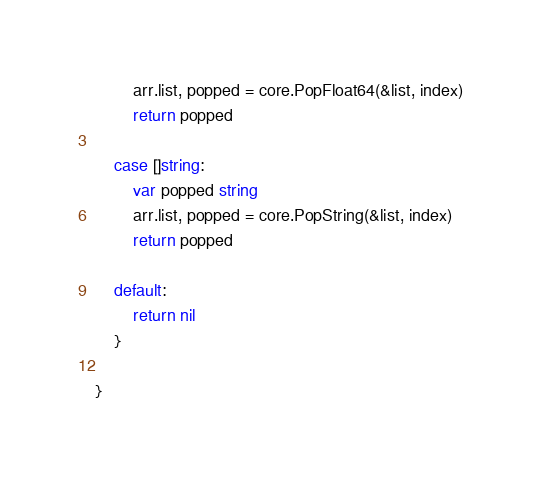<code> <loc_0><loc_0><loc_500><loc_500><_Go_>		arr.list, popped = core.PopFloat64(&list, index)
		return popped

	case []string:
		var popped string
		arr.list, popped = core.PopString(&list, index)
		return popped

	default:
		return nil
	}

}
</code> 